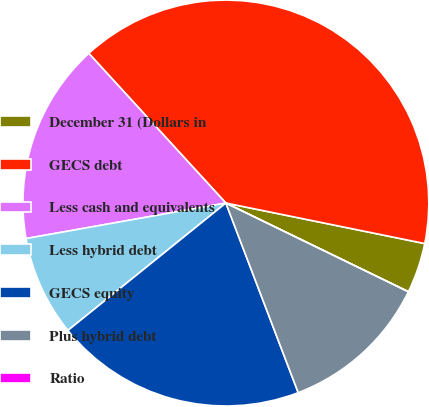<chart> <loc_0><loc_0><loc_500><loc_500><pie_chart><fcel>December 31 (Dollars in<fcel>GECS debt<fcel>Less cash and equivalents<fcel>Less hybrid debt<fcel>GECS equity<fcel>Plus hybrid debt<fcel>Ratio<nl><fcel>4.0%<fcel>40.0%<fcel>16.0%<fcel>8.0%<fcel>20.0%<fcel>12.0%<fcel>0.0%<nl></chart> 